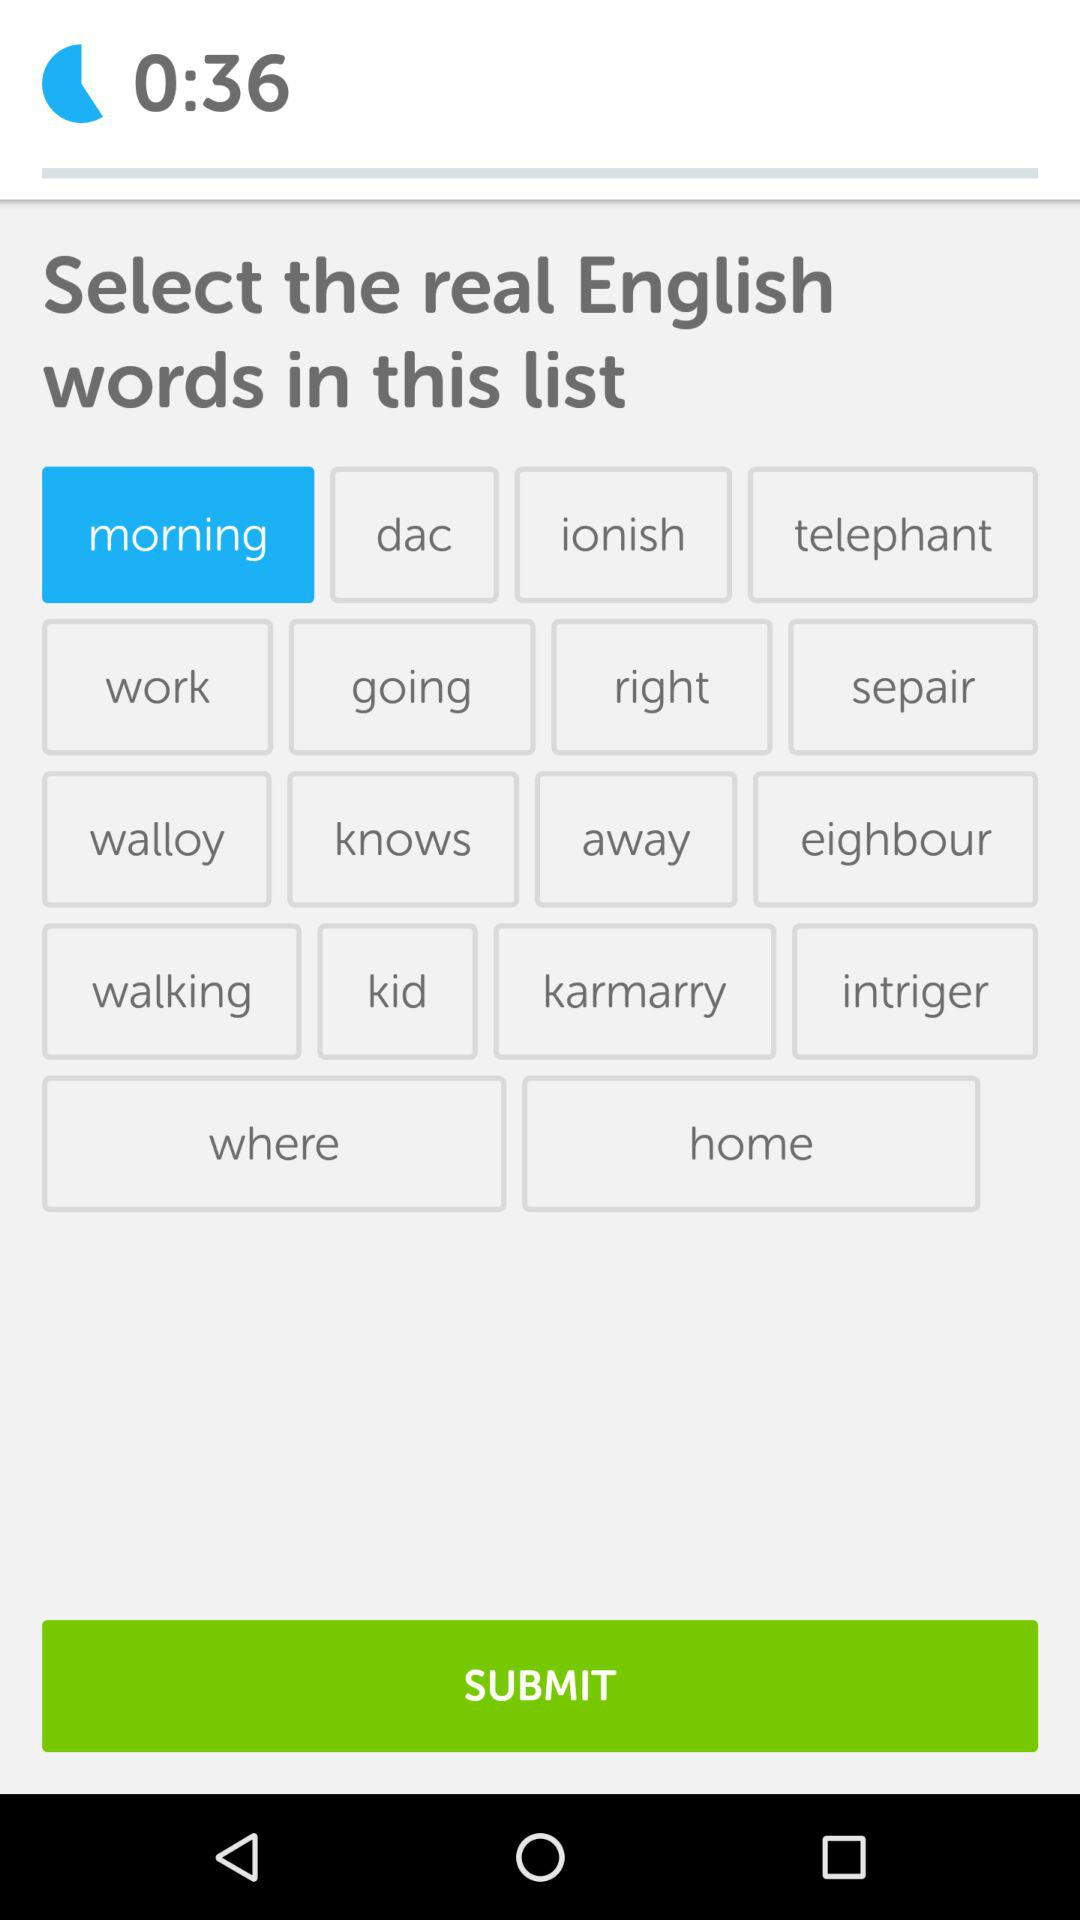What's the remaining time? The remaining time is 36 seconds. 